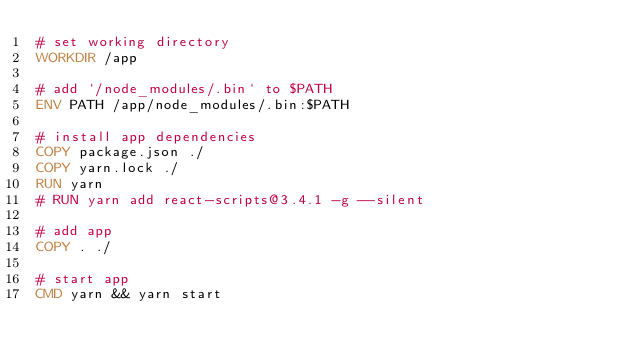Convert code to text. <code><loc_0><loc_0><loc_500><loc_500><_Dockerfile_># set working directory
WORKDIR /app

# add `/node_modules/.bin` to $PATH
ENV PATH /app/node_modules/.bin:$PATH

# install app dependencies
COPY package.json ./
COPY yarn.lock ./
RUN yarn
# RUN yarn add react-scripts@3.4.1 -g --silent

# add app
COPY . ./

# start app
CMD yarn && yarn start</code> 